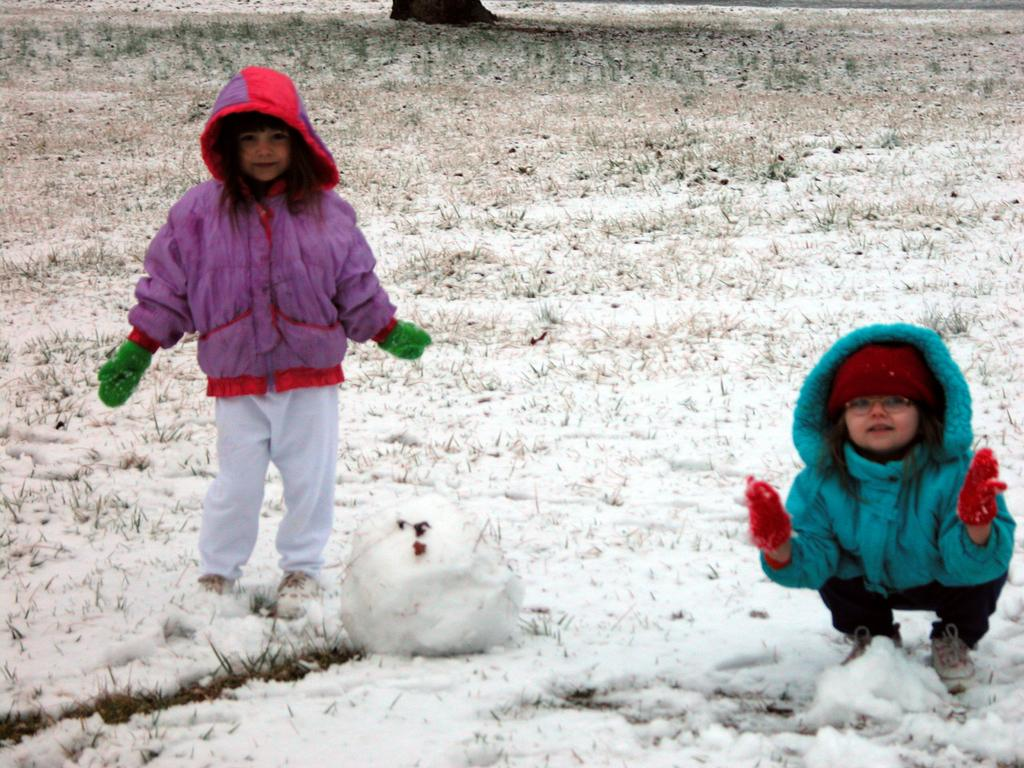How many girls are present in the image? There are two girls in the image. What are the positions of the girls in the image? One girl is standing, and the other girl is in a squat position. What type of terrain is visible in the image? There is grass and snow visible in the image. What is the size of the example in the image? There is no example present in the image, so it is not possible to determine its size. 